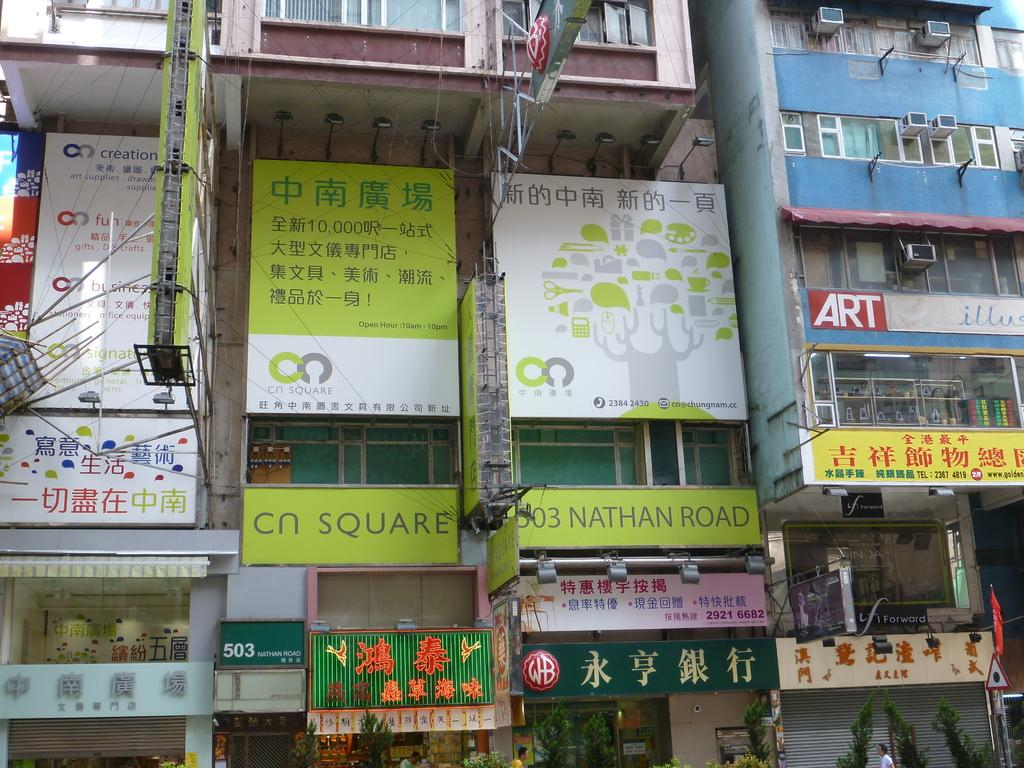<image>
Provide a brief description of the given image. A few buildings linked together and one of them has a sign that says "ART". 